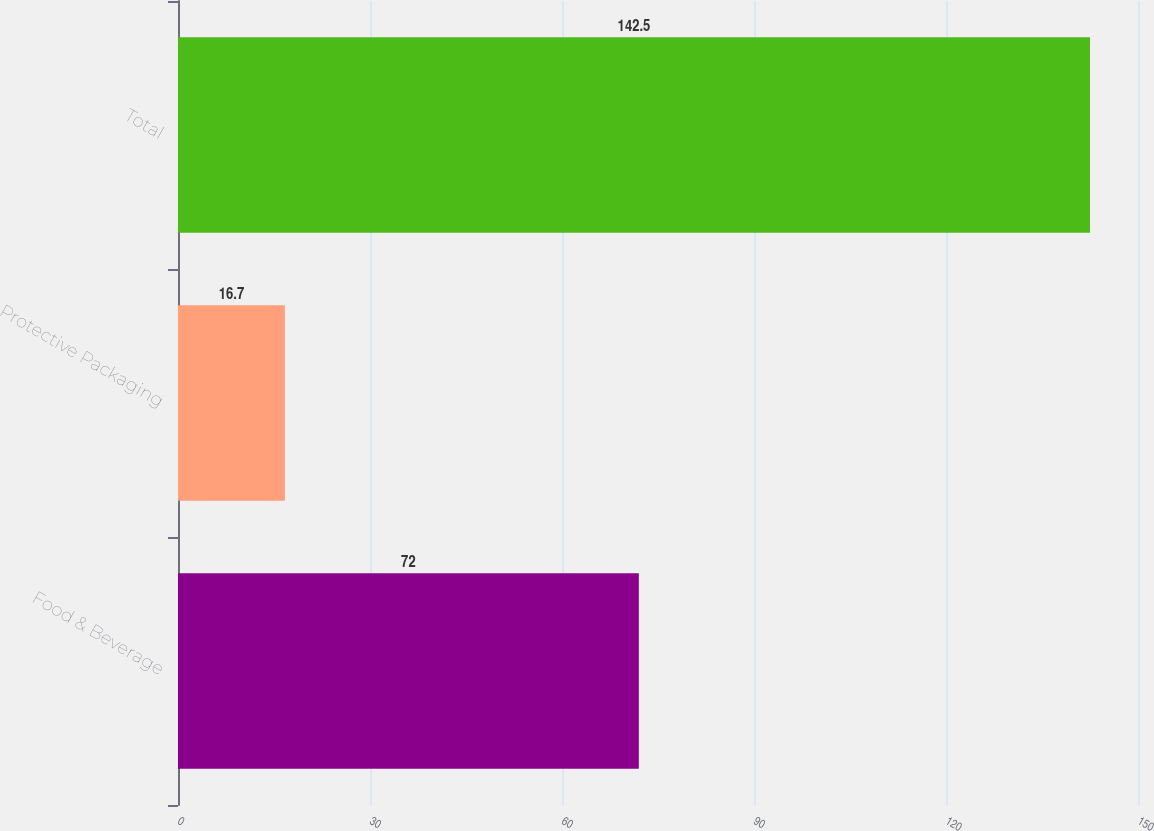<chart> <loc_0><loc_0><loc_500><loc_500><bar_chart><fcel>Food & Beverage<fcel>Protective Packaging<fcel>Total<nl><fcel>72<fcel>16.7<fcel>142.5<nl></chart> 